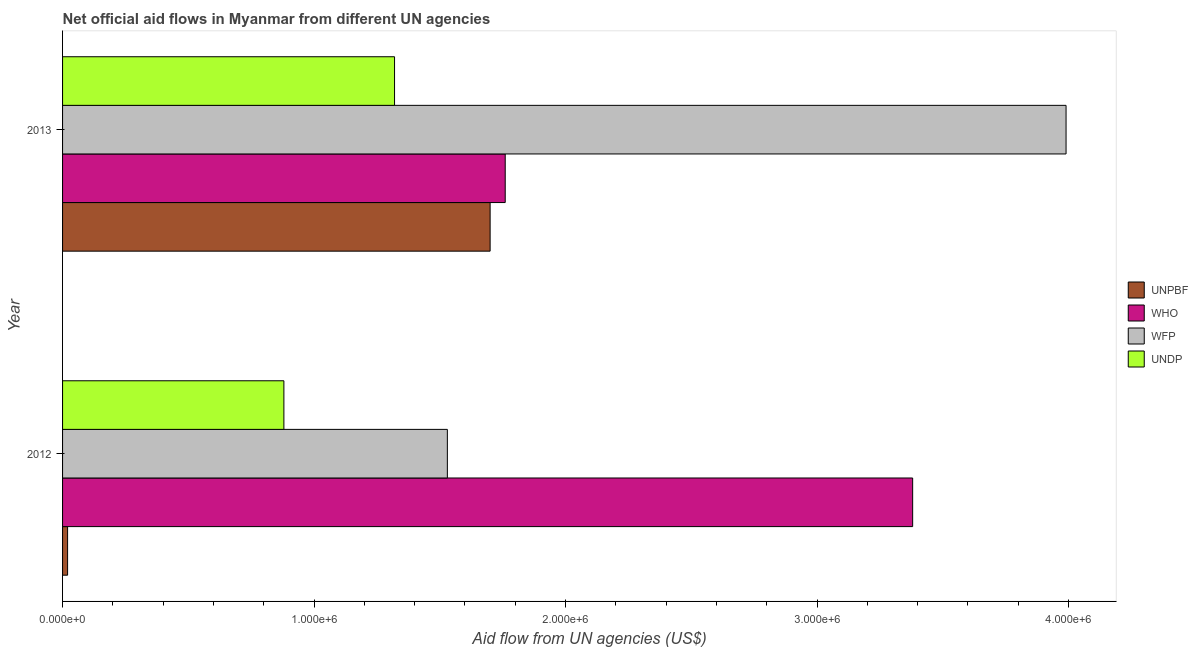How many groups of bars are there?
Offer a very short reply. 2. What is the label of the 2nd group of bars from the top?
Your answer should be compact. 2012. In how many cases, is the number of bars for a given year not equal to the number of legend labels?
Your answer should be compact. 0. What is the amount of aid given by unpbf in 2012?
Provide a short and direct response. 2.00e+04. Across all years, what is the maximum amount of aid given by who?
Provide a short and direct response. 3.38e+06. Across all years, what is the minimum amount of aid given by undp?
Your answer should be very brief. 8.80e+05. In which year was the amount of aid given by unpbf minimum?
Your answer should be very brief. 2012. What is the total amount of aid given by who in the graph?
Keep it short and to the point. 5.14e+06. What is the difference between the amount of aid given by unpbf in 2012 and that in 2013?
Provide a succinct answer. -1.68e+06. What is the difference between the amount of aid given by who in 2013 and the amount of aid given by undp in 2012?
Your response must be concise. 8.80e+05. What is the average amount of aid given by undp per year?
Provide a short and direct response. 1.10e+06. In the year 2013, what is the difference between the amount of aid given by undp and amount of aid given by wfp?
Offer a terse response. -2.67e+06. What is the ratio of the amount of aid given by unpbf in 2012 to that in 2013?
Keep it short and to the point. 0.01. Is it the case that in every year, the sum of the amount of aid given by who and amount of aid given by wfp is greater than the sum of amount of aid given by unpbf and amount of aid given by undp?
Provide a succinct answer. Yes. What does the 1st bar from the top in 2013 represents?
Give a very brief answer. UNDP. What does the 2nd bar from the bottom in 2013 represents?
Your response must be concise. WHO. Is it the case that in every year, the sum of the amount of aid given by unpbf and amount of aid given by who is greater than the amount of aid given by wfp?
Ensure brevity in your answer.  No. How many bars are there?
Ensure brevity in your answer.  8. Are all the bars in the graph horizontal?
Your answer should be compact. Yes. Does the graph contain any zero values?
Make the answer very short. No. Does the graph contain grids?
Offer a very short reply. No. How many legend labels are there?
Offer a terse response. 4. What is the title of the graph?
Ensure brevity in your answer.  Net official aid flows in Myanmar from different UN agencies. What is the label or title of the X-axis?
Your answer should be very brief. Aid flow from UN agencies (US$). What is the label or title of the Y-axis?
Provide a succinct answer. Year. What is the Aid flow from UN agencies (US$) in WHO in 2012?
Make the answer very short. 3.38e+06. What is the Aid flow from UN agencies (US$) in WFP in 2012?
Your answer should be compact. 1.53e+06. What is the Aid flow from UN agencies (US$) in UNDP in 2012?
Your answer should be very brief. 8.80e+05. What is the Aid flow from UN agencies (US$) in UNPBF in 2013?
Your response must be concise. 1.70e+06. What is the Aid flow from UN agencies (US$) of WHO in 2013?
Offer a very short reply. 1.76e+06. What is the Aid flow from UN agencies (US$) of WFP in 2013?
Your answer should be compact. 3.99e+06. What is the Aid flow from UN agencies (US$) of UNDP in 2013?
Offer a terse response. 1.32e+06. Across all years, what is the maximum Aid flow from UN agencies (US$) in UNPBF?
Ensure brevity in your answer.  1.70e+06. Across all years, what is the maximum Aid flow from UN agencies (US$) in WHO?
Your response must be concise. 3.38e+06. Across all years, what is the maximum Aid flow from UN agencies (US$) in WFP?
Give a very brief answer. 3.99e+06. Across all years, what is the maximum Aid flow from UN agencies (US$) in UNDP?
Offer a very short reply. 1.32e+06. Across all years, what is the minimum Aid flow from UN agencies (US$) of UNPBF?
Keep it short and to the point. 2.00e+04. Across all years, what is the minimum Aid flow from UN agencies (US$) in WHO?
Provide a short and direct response. 1.76e+06. Across all years, what is the minimum Aid flow from UN agencies (US$) in WFP?
Your response must be concise. 1.53e+06. Across all years, what is the minimum Aid flow from UN agencies (US$) in UNDP?
Your answer should be compact. 8.80e+05. What is the total Aid flow from UN agencies (US$) of UNPBF in the graph?
Provide a succinct answer. 1.72e+06. What is the total Aid flow from UN agencies (US$) in WHO in the graph?
Give a very brief answer. 5.14e+06. What is the total Aid flow from UN agencies (US$) in WFP in the graph?
Provide a succinct answer. 5.52e+06. What is the total Aid flow from UN agencies (US$) of UNDP in the graph?
Offer a terse response. 2.20e+06. What is the difference between the Aid flow from UN agencies (US$) of UNPBF in 2012 and that in 2013?
Your answer should be compact. -1.68e+06. What is the difference between the Aid flow from UN agencies (US$) of WHO in 2012 and that in 2013?
Your response must be concise. 1.62e+06. What is the difference between the Aid flow from UN agencies (US$) in WFP in 2012 and that in 2013?
Offer a very short reply. -2.46e+06. What is the difference between the Aid flow from UN agencies (US$) of UNDP in 2012 and that in 2013?
Ensure brevity in your answer.  -4.40e+05. What is the difference between the Aid flow from UN agencies (US$) in UNPBF in 2012 and the Aid flow from UN agencies (US$) in WHO in 2013?
Provide a succinct answer. -1.74e+06. What is the difference between the Aid flow from UN agencies (US$) in UNPBF in 2012 and the Aid flow from UN agencies (US$) in WFP in 2013?
Provide a succinct answer. -3.97e+06. What is the difference between the Aid flow from UN agencies (US$) in UNPBF in 2012 and the Aid flow from UN agencies (US$) in UNDP in 2013?
Your answer should be compact. -1.30e+06. What is the difference between the Aid flow from UN agencies (US$) of WHO in 2012 and the Aid flow from UN agencies (US$) of WFP in 2013?
Keep it short and to the point. -6.10e+05. What is the difference between the Aid flow from UN agencies (US$) of WHO in 2012 and the Aid flow from UN agencies (US$) of UNDP in 2013?
Ensure brevity in your answer.  2.06e+06. What is the difference between the Aid flow from UN agencies (US$) of WFP in 2012 and the Aid flow from UN agencies (US$) of UNDP in 2013?
Your response must be concise. 2.10e+05. What is the average Aid flow from UN agencies (US$) of UNPBF per year?
Your response must be concise. 8.60e+05. What is the average Aid flow from UN agencies (US$) of WHO per year?
Ensure brevity in your answer.  2.57e+06. What is the average Aid flow from UN agencies (US$) in WFP per year?
Your response must be concise. 2.76e+06. What is the average Aid flow from UN agencies (US$) in UNDP per year?
Give a very brief answer. 1.10e+06. In the year 2012, what is the difference between the Aid flow from UN agencies (US$) in UNPBF and Aid flow from UN agencies (US$) in WHO?
Your response must be concise. -3.36e+06. In the year 2012, what is the difference between the Aid flow from UN agencies (US$) of UNPBF and Aid flow from UN agencies (US$) of WFP?
Offer a very short reply. -1.51e+06. In the year 2012, what is the difference between the Aid flow from UN agencies (US$) of UNPBF and Aid flow from UN agencies (US$) of UNDP?
Your answer should be very brief. -8.60e+05. In the year 2012, what is the difference between the Aid flow from UN agencies (US$) in WHO and Aid flow from UN agencies (US$) in WFP?
Ensure brevity in your answer.  1.85e+06. In the year 2012, what is the difference between the Aid flow from UN agencies (US$) of WHO and Aid flow from UN agencies (US$) of UNDP?
Give a very brief answer. 2.50e+06. In the year 2012, what is the difference between the Aid flow from UN agencies (US$) of WFP and Aid flow from UN agencies (US$) of UNDP?
Your answer should be very brief. 6.50e+05. In the year 2013, what is the difference between the Aid flow from UN agencies (US$) of UNPBF and Aid flow from UN agencies (US$) of WHO?
Your answer should be very brief. -6.00e+04. In the year 2013, what is the difference between the Aid flow from UN agencies (US$) of UNPBF and Aid flow from UN agencies (US$) of WFP?
Your answer should be very brief. -2.29e+06. In the year 2013, what is the difference between the Aid flow from UN agencies (US$) of UNPBF and Aid flow from UN agencies (US$) of UNDP?
Provide a short and direct response. 3.80e+05. In the year 2013, what is the difference between the Aid flow from UN agencies (US$) of WHO and Aid flow from UN agencies (US$) of WFP?
Provide a short and direct response. -2.23e+06. In the year 2013, what is the difference between the Aid flow from UN agencies (US$) in WFP and Aid flow from UN agencies (US$) in UNDP?
Keep it short and to the point. 2.67e+06. What is the ratio of the Aid flow from UN agencies (US$) of UNPBF in 2012 to that in 2013?
Provide a short and direct response. 0.01. What is the ratio of the Aid flow from UN agencies (US$) in WHO in 2012 to that in 2013?
Keep it short and to the point. 1.92. What is the ratio of the Aid flow from UN agencies (US$) in WFP in 2012 to that in 2013?
Ensure brevity in your answer.  0.38. What is the difference between the highest and the second highest Aid flow from UN agencies (US$) in UNPBF?
Ensure brevity in your answer.  1.68e+06. What is the difference between the highest and the second highest Aid flow from UN agencies (US$) in WHO?
Provide a short and direct response. 1.62e+06. What is the difference between the highest and the second highest Aid flow from UN agencies (US$) of WFP?
Your answer should be compact. 2.46e+06. What is the difference between the highest and the lowest Aid flow from UN agencies (US$) in UNPBF?
Your answer should be very brief. 1.68e+06. What is the difference between the highest and the lowest Aid flow from UN agencies (US$) in WHO?
Give a very brief answer. 1.62e+06. What is the difference between the highest and the lowest Aid flow from UN agencies (US$) in WFP?
Provide a succinct answer. 2.46e+06. 